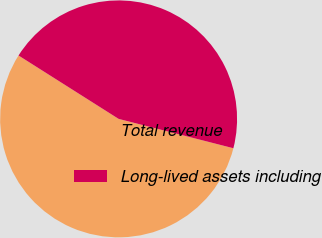Convert chart. <chart><loc_0><loc_0><loc_500><loc_500><pie_chart><fcel>Total revenue<fcel>Long-lived assets including<nl><fcel>55.0%<fcel>45.0%<nl></chart> 